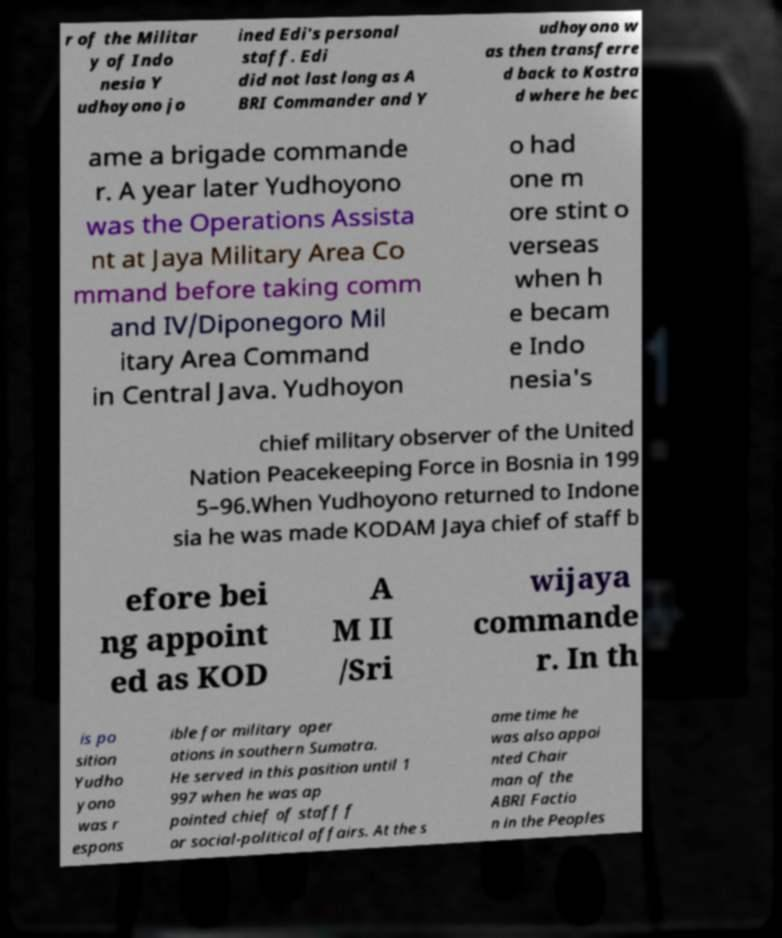Please identify and transcribe the text found in this image. r of the Militar y of Indo nesia Y udhoyono jo ined Edi's personal staff. Edi did not last long as A BRI Commander and Y udhoyono w as then transferre d back to Kostra d where he bec ame a brigade commande r. A year later Yudhoyono was the Operations Assista nt at Jaya Military Area Co mmand before taking comm and IV/Diponegoro Mil itary Area Command in Central Java. Yudhoyon o had one m ore stint o verseas when h e becam e Indo nesia's chief military observer of the United Nation Peacekeeping Force in Bosnia in 199 5–96.When Yudhoyono returned to Indone sia he was made KODAM Jaya chief of staff b efore bei ng appoint ed as KOD A M II /Sri wijaya commande r. In th is po sition Yudho yono was r espons ible for military oper ations in southern Sumatra. He served in this position until 1 997 when he was ap pointed chief of staff f or social-political affairs. At the s ame time he was also appoi nted Chair man of the ABRI Factio n in the Peoples 